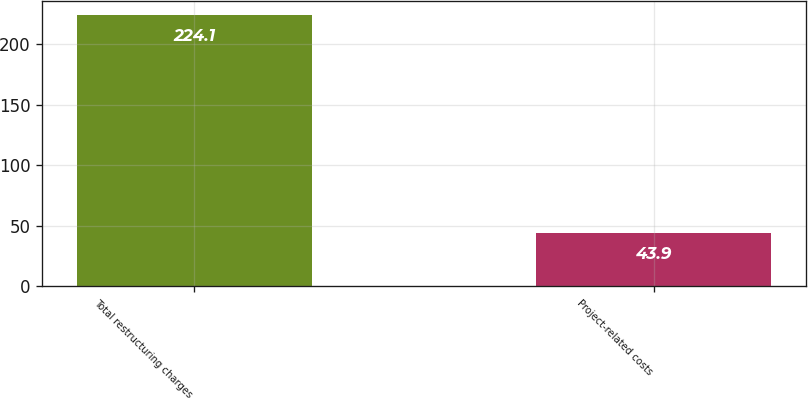Convert chart to OTSL. <chart><loc_0><loc_0><loc_500><loc_500><bar_chart><fcel>Total restructuring charges<fcel>Project-related costs<nl><fcel>224.1<fcel>43.9<nl></chart> 